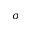<formula> <loc_0><loc_0><loc_500><loc_500>\sigma</formula> 